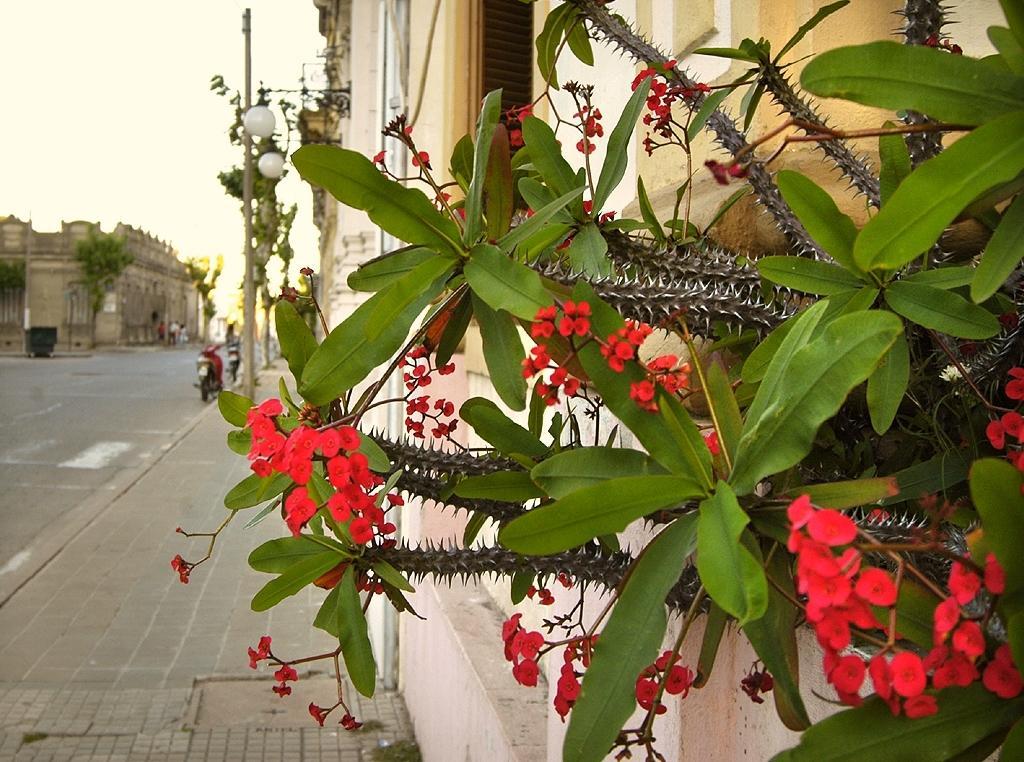Can you describe this image briefly? In this picture I can see plants in front on which there are flowers which are of red in color and I see the building behind this plants. In the background I see the buildings and the road and I see few trees and I see the sky. 